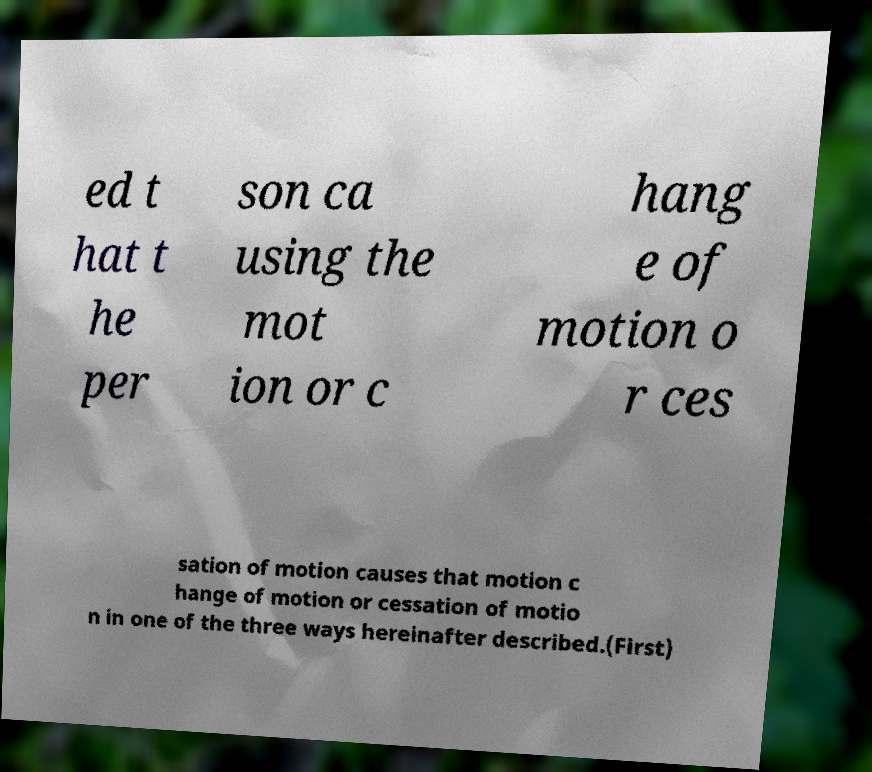For documentation purposes, I need the text within this image transcribed. Could you provide that? ed t hat t he per son ca using the mot ion or c hang e of motion o r ces sation of motion causes that motion c hange of motion or cessation of motio n in one of the three ways hereinafter described.(First) 